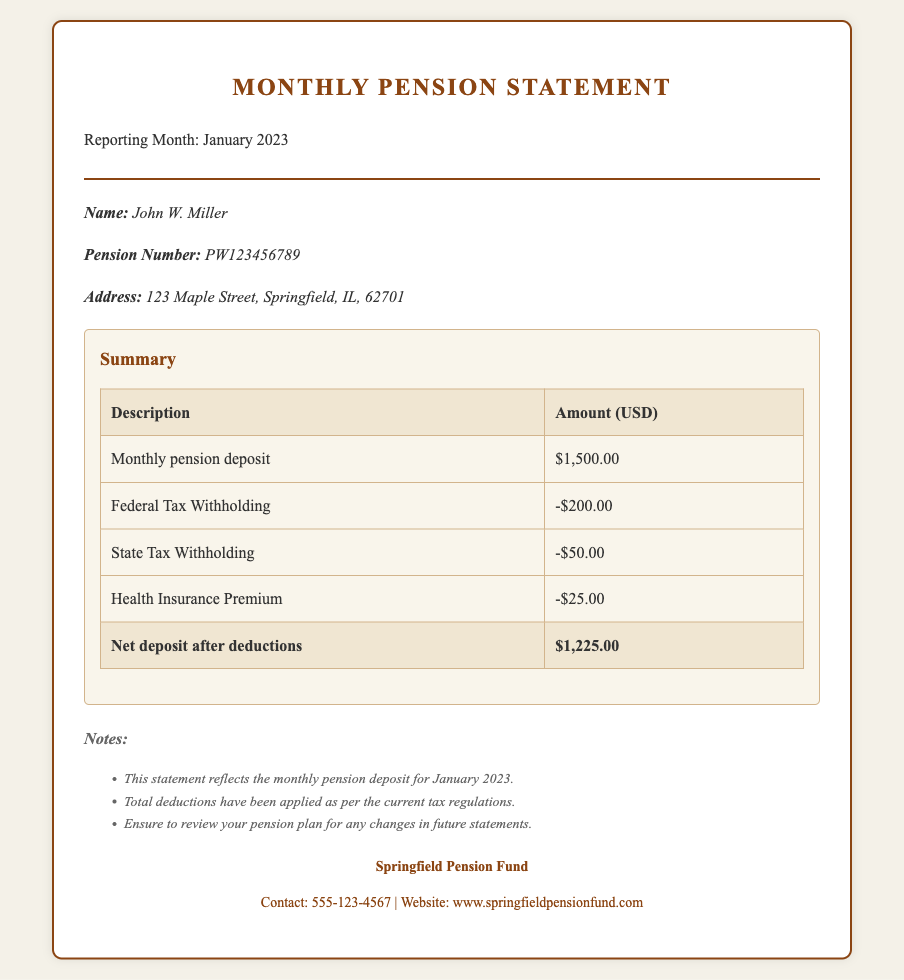What is the name of the pensioner? The name of the pensioner is mentioned in the document under pensioner details.
Answer: John W. Miller What is the total amount deposited for January 2023? The total amount deposited is listed in the summary table as the monthly pension deposit.
Answer: $1,500.00 What is the amount withheld for federal tax? The amount for federal tax withholding is provided in the deductions section of the summary.
Answer: -$200.00 What is the net deposit after deductions? The net deposit is calculated after applying the deductions and is stated at the bottom of the summary table.
Answer: $1,225.00 How much is deducted for health insurance? The health insurance premium amount deducted is specified in the summary table.
Answer: -$25.00 What is the pension number of the pensioner? The pension number is clearly indicated in the pensioner details section of the document.
Answer: PW123456789 How many deductions are listed in the summary? The summary includes multiple deductions, which can be counted in the table.
Answer: 3 What organization is managing the pension fund? The organization responsible for the pension fund is mentioned at the end of the document.
Answer: Springfield Pension Fund What is the contact number for the pension fund? The contact number for the pension fund is provided under the provider details section.
Answer: 555-123-4567 